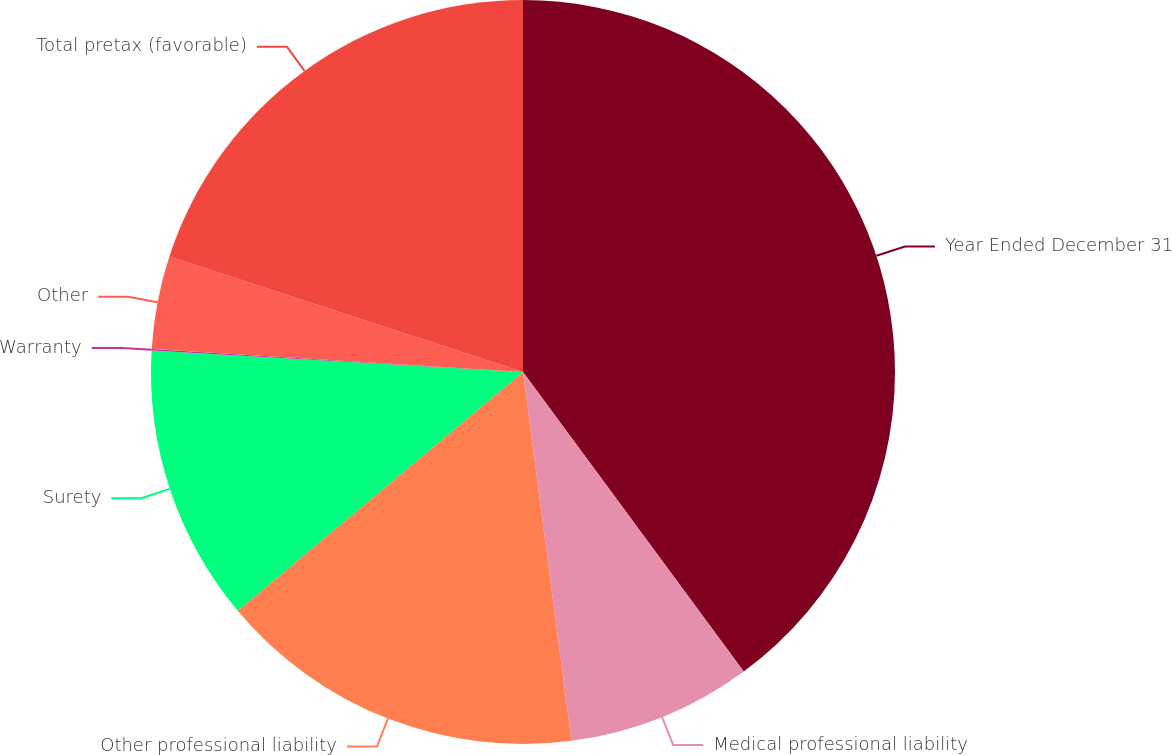Convert chart to OTSL. <chart><loc_0><loc_0><loc_500><loc_500><pie_chart><fcel>Year Ended December 31<fcel>Medical professional liability<fcel>Other professional liability<fcel>Surety<fcel>Warranty<fcel>Other<fcel>Total pretax (favorable)<nl><fcel>39.89%<fcel>8.03%<fcel>15.99%<fcel>12.01%<fcel>0.06%<fcel>4.04%<fcel>19.98%<nl></chart> 